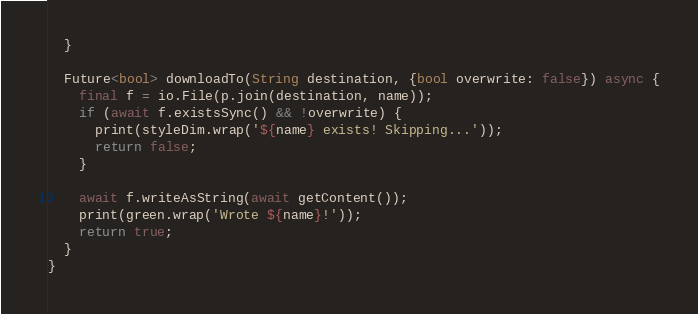<code> <loc_0><loc_0><loc_500><loc_500><_Dart_>  }

  Future<bool> downloadTo(String destination, {bool overwrite: false}) async {
    final f = io.File(p.join(destination, name));
    if (await f.existsSync() && !overwrite) {
      print(styleDim.wrap('${name} exists! Skipping...'));
      return false;
    }

    await f.writeAsString(await getContent());
    print(green.wrap('Wrote ${name}!'));
    return true;
  }
}
</code> 